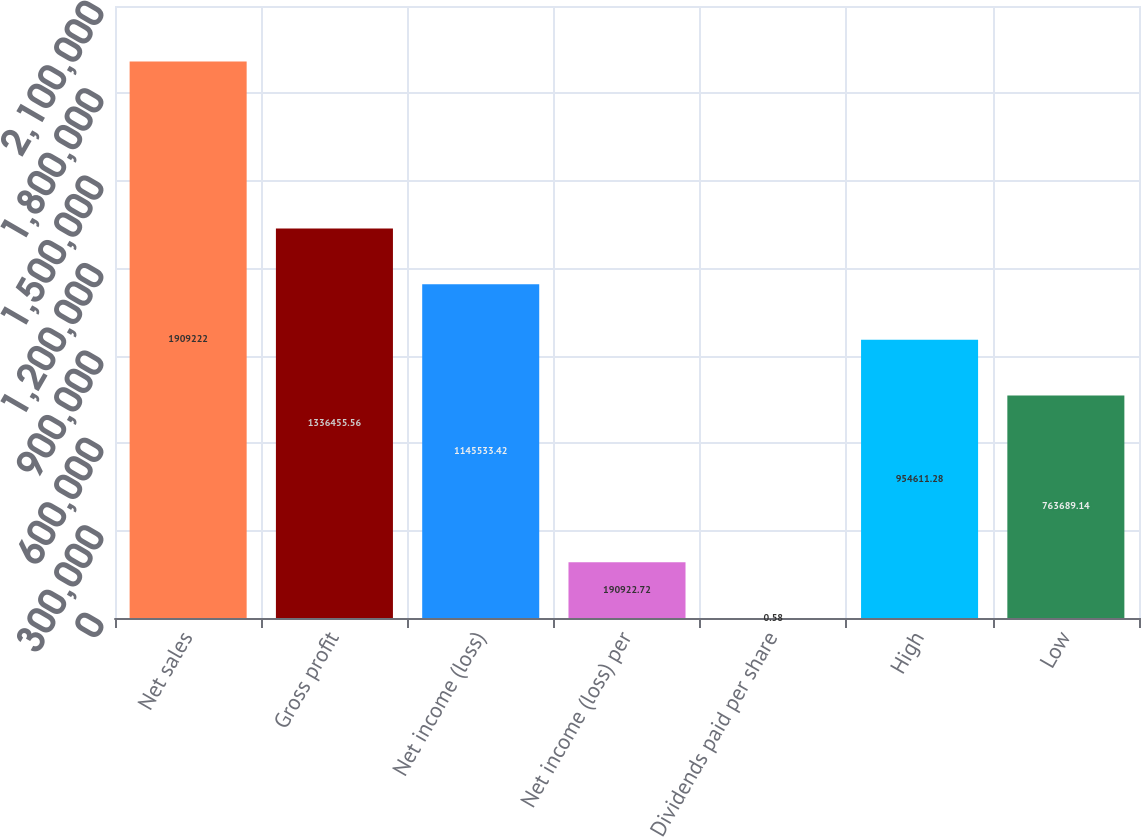Convert chart to OTSL. <chart><loc_0><loc_0><loc_500><loc_500><bar_chart><fcel>Net sales<fcel>Gross profit<fcel>Net income (loss)<fcel>Net income (loss) per<fcel>Dividends paid per share<fcel>High<fcel>Low<nl><fcel>1.90922e+06<fcel>1.33646e+06<fcel>1.14553e+06<fcel>190923<fcel>0.58<fcel>954611<fcel>763689<nl></chart> 